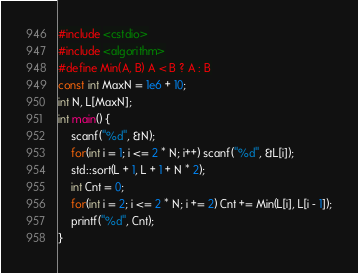<code> <loc_0><loc_0><loc_500><loc_500><_C++_>#include <cstdio>
#include <algorithm>
#define Min(A, B) A < B ? A : B
const int MaxN = 1e6 + 10;
int N, L[MaxN];
int main() {
	scanf("%d", &N);
	for(int i = 1; i <= 2 * N; i++) scanf("%d", &L[i]);		
	std::sort(L + 1, L + 1 + N * 2);
	int Cnt = 0;
	for(int i = 2; i <= 2 * N; i += 2) Cnt += Min(L[i], L[i - 1]);
	printf("%d", Cnt);
} </code> 